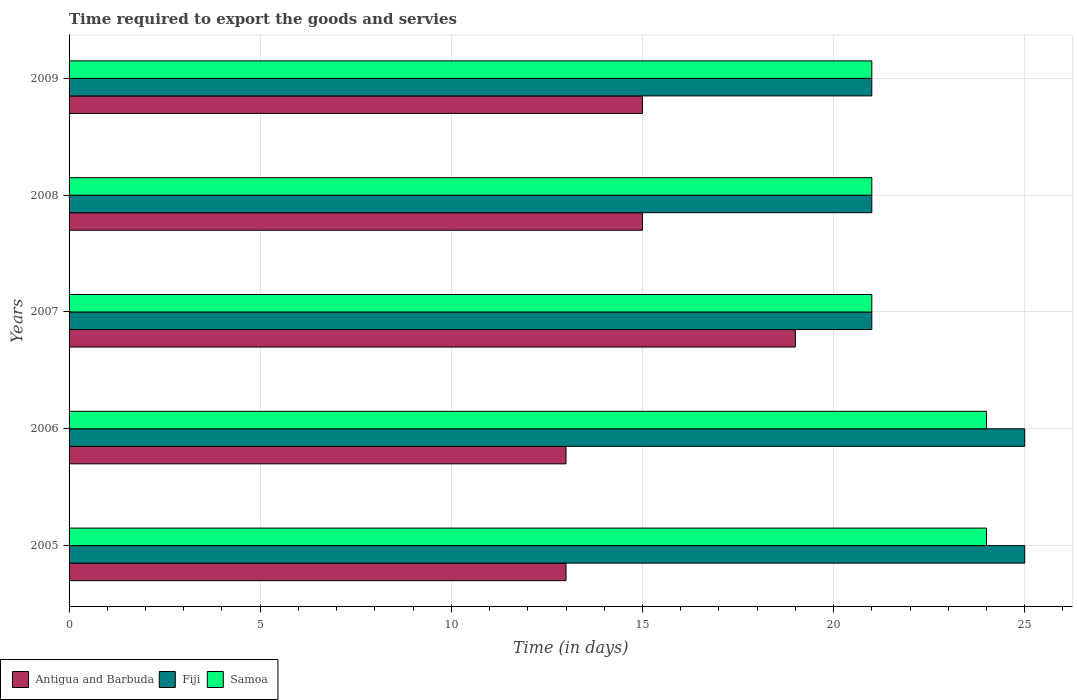Are the number of bars per tick equal to the number of legend labels?
Offer a very short reply. Yes. How many bars are there on the 3rd tick from the top?
Your answer should be compact. 3. What is the number of days required to export the goods and services in Fiji in 2007?
Offer a terse response. 21. Across all years, what is the maximum number of days required to export the goods and services in Fiji?
Make the answer very short. 25. Across all years, what is the minimum number of days required to export the goods and services in Fiji?
Give a very brief answer. 21. In which year was the number of days required to export the goods and services in Samoa maximum?
Offer a terse response. 2005. What is the total number of days required to export the goods and services in Fiji in the graph?
Your answer should be compact. 113. What is the difference between the number of days required to export the goods and services in Fiji in 2007 and that in 2008?
Your response must be concise. 0. What is the difference between the number of days required to export the goods and services in Antigua and Barbuda in 2006 and the number of days required to export the goods and services in Fiji in 2008?
Your answer should be very brief. -8. In the year 2006, what is the difference between the number of days required to export the goods and services in Samoa and number of days required to export the goods and services in Antigua and Barbuda?
Give a very brief answer. 11. Is the number of days required to export the goods and services in Fiji in 2005 less than that in 2006?
Offer a terse response. No. Is the difference between the number of days required to export the goods and services in Samoa in 2005 and 2006 greater than the difference between the number of days required to export the goods and services in Antigua and Barbuda in 2005 and 2006?
Provide a short and direct response. No. What is the difference between the highest and the lowest number of days required to export the goods and services in Samoa?
Ensure brevity in your answer.  3. In how many years, is the number of days required to export the goods and services in Samoa greater than the average number of days required to export the goods and services in Samoa taken over all years?
Give a very brief answer. 2. Is the sum of the number of days required to export the goods and services in Samoa in 2005 and 2006 greater than the maximum number of days required to export the goods and services in Fiji across all years?
Your response must be concise. Yes. What does the 2nd bar from the top in 2005 represents?
Offer a terse response. Fiji. What does the 1st bar from the bottom in 2008 represents?
Keep it short and to the point. Antigua and Barbuda. Are all the bars in the graph horizontal?
Ensure brevity in your answer.  Yes. What is the difference between two consecutive major ticks on the X-axis?
Ensure brevity in your answer.  5. Are the values on the major ticks of X-axis written in scientific E-notation?
Make the answer very short. No. Does the graph contain grids?
Your answer should be compact. Yes. Where does the legend appear in the graph?
Provide a short and direct response. Bottom left. What is the title of the graph?
Offer a terse response. Time required to export the goods and servies. What is the label or title of the X-axis?
Provide a short and direct response. Time (in days). What is the Time (in days) in Samoa in 2005?
Ensure brevity in your answer.  24. What is the Time (in days) of Antigua and Barbuda in 2007?
Ensure brevity in your answer.  19. What is the Time (in days) in Fiji in 2007?
Offer a terse response. 21. What is the Time (in days) of Samoa in 2007?
Your answer should be compact. 21. What is the Time (in days) of Antigua and Barbuda in 2009?
Give a very brief answer. 15. What is the Time (in days) of Fiji in 2009?
Provide a short and direct response. 21. What is the Time (in days) of Samoa in 2009?
Your response must be concise. 21. Across all years, what is the maximum Time (in days) in Fiji?
Make the answer very short. 25. What is the total Time (in days) in Antigua and Barbuda in the graph?
Provide a succinct answer. 75. What is the total Time (in days) in Fiji in the graph?
Offer a terse response. 113. What is the total Time (in days) in Samoa in the graph?
Make the answer very short. 111. What is the difference between the Time (in days) of Fiji in 2005 and that in 2006?
Your answer should be compact. 0. What is the difference between the Time (in days) in Fiji in 2005 and that in 2007?
Ensure brevity in your answer.  4. What is the difference between the Time (in days) in Samoa in 2005 and that in 2009?
Give a very brief answer. 3. What is the difference between the Time (in days) of Antigua and Barbuda in 2006 and that in 2007?
Make the answer very short. -6. What is the difference between the Time (in days) in Fiji in 2006 and that in 2007?
Your answer should be compact. 4. What is the difference between the Time (in days) of Antigua and Barbuda in 2006 and that in 2008?
Your response must be concise. -2. What is the difference between the Time (in days) in Fiji in 2006 and that in 2009?
Your answer should be compact. 4. What is the difference between the Time (in days) in Samoa in 2006 and that in 2009?
Your answer should be compact. 3. What is the difference between the Time (in days) in Fiji in 2007 and that in 2008?
Your answer should be compact. 0. What is the difference between the Time (in days) of Samoa in 2007 and that in 2008?
Provide a short and direct response. 0. What is the difference between the Time (in days) of Antigua and Barbuda in 2007 and that in 2009?
Offer a very short reply. 4. What is the difference between the Time (in days) in Samoa in 2008 and that in 2009?
Your answer should be very brief. 0. What is the difference between the Time (in days) of Antigua and Barbuda in 2005 and the Time (in days) of Fiji in 2006?
Offer a terse response. -12. What is the difference between the Time (in days) in Antigua and Barbuda in 2005 and the Time (in days) in Samoa in 2007?
Your answer should be compact. -8. What is the difference between the Time (in days) in Antigua and Barbuda in 2005 and the Time (in days) in Samoa in 2008?
Your response must be concise. -8. What is the difference between the Time (in days) in Fiji in 2005 and the Time (in days) in Samoa in 2008?
Offer a terse response. 4. What is the difference between the Time (in days) in Antigua and Barbuda in 2005 and the Time (in days) in Fiji in 2009?
Ensure brevity in your answer.  -8. What is the difference between the Time (in days) of Fiji in 2005 and the Time (in days) of Samoa in 2009?
Offer a very short reply. 4. What is the difference between the Time (in days) of Antigua and Barbuda in 2006 and the Time (in days) of Fiji in 2007?
Offer a very short reply. -8. What is the difference between the Time (in days) of Fiji in 2006 and the Time (in days) of Samoa in 2007?
Provide a short and direct response. 4. What is the difference between the Time (in days) in Antigua and Barbuda in 2006 and the Time (in days) in Fiji in 2008?
Ensure brevity in your answer.  -8. What is the difference between the Time (in days) of Antigua and Barbuda in 2006 and the Time (in days) of Samoa in 2008?
Give a very brief answer. -8. What is the difference between the Time (in days) of Antigua and Barbuda in 2006 and the Time (in days) of Samoa in 2009?
Provide a succinct answer. -8. What is the difference between the Time (in days) of Fiji in 2006 and the Time (in days) of Samoa in 2009?
Ensure brevity in your answer.  4. What is the difference between the Time (in days) of Antigua and Barbuda in 2007 and the Time (in days) of Samoa in 2009?
Your answer should be compact. -2. What is the difference between the Time (in days) of Fiji in 2007 and the Time (in days) of Samoa in 2009?
Your answer should be very brief. 0. What is the difference between the Time (in days) in Fiji in 2008 and the Time (in days) in Samoa in 2009?
Your answer should be compact. 0. What is the average Time (in days) of Fiji per year?
Provide a succinct answer. 22.6. What is the average Time (in days) in Samoa per year?
Keep it short and to the point. 22.2. In the year 2006, what is the difference between the Time (in days) of Antigua and Barbuda and Time (in days) of Fiji?
Keep it short and to the point. -12. In the year 2006, what is the difference between the Time (in days) of Fiji and Time (in days) of Samoa?
Give a very brief answer. 1. In the year 2008, what is the difference between the Time (in days) in Antigua and Barbuda and Time (in days) in Fiji?
Give a very brief answer. -6. In the year 2008, what is the difference between the Time (in days) of Antigua and Barbuda and Time (in days) of Samoa?
Make the answer very short. -6. In the year 2009, what is the difference between the Time (in days) in Antigua and Barbuda and Time (in days) in Fiji?
Your answer should be compact. -6. In the year 2009, what is the difference between the Time (in days) in Fiji and Time (in days) in Samoa?
Your answer should be compact. 0. What is the ratio of the Time (in days) in Antigua and Barbuda in 2005 to that in 2007?
Offer a very short reply. 0.68. What is the ratio of the Time (in days) in Fiji in 2005 to that in 2007?
Ensure brevity in your answer.  1.19. What is the ratio of the Time (in days) of Antigua and Barbuda in 2005 to that in 2008?
Provide a succinct answer. 0.87. What is the ratio of the Time (in days) in Fiji in 2005 to that in 2008?
Provide a short and direct response. 1.19. What is the ratio of the Time (in days) in Antigua and Barbuda in 2005 to that in 2009?
Give a very brief answer. 0.87. What is the ratio of the Time (in days) in Fiji in 2005 to that in 2009?
Provide a short and direct response. 1.19. What is the ratio of the Time (in days) in Antigua and Barbuda in 2006 to that in 2007?
Provide a succinct answer. 0.68. What is the ratio of the Time (in days) of Fiji in 2006 to that in 2007?
Your response must be concise. 1.19. What is the ratio of the Time (in days) of Antigua and Barbuda in 2006 to that in 2008?
Give a very brief answer. 0.87. What is the ratio of the Time (in days) of Fiji in 2006 to that in 2008?
Your answer should be compact. 1.19. What is the ratio of the Time (in days) in Samoa in 2006 to that in 2008?
Make the answer very short. 1.14. What is the ratio of the Time (in days) of Antigua and Barbuda in 2006 to that in 2009?
Keep it short and to the point. 0.87. What is the ratio of the Time (in days) of Fiji in 2006 to that in 2009?
Your answer should be very brief. 1.19. What is the ratio of the Time (in days) of Samoa in 2006 to that in 2009?
Make the answer very short. 1.14. What is the ratio of the Time (in days) of Antigua and Barbuda in 2007 to that in 2008?
Ensure brevity in your answer.  1.27. What is the ratio of the Time (in days) of Antigua and Barbuda in 2007 to that in 2009?
Offer a very short reply. 1.27. What is the ratio of the Time (in days) of Fiji in 2007 to that in 2009?
Offer a very short reply. 1. What is the difference between the highest and the second highest Time (in days) of Antigua and Barbuda?
Keep it short and to the point. 4. What is the difference between the highest and the second highest Time (in days) in Fiji?
Your response must be concise. 0. What is the difference between the highest and the second highest Time (in days) of Samoa?
Provide a short and direct response. 0. What is the difference between the highest and the lowest Time (in days) in Antigua and Barbuda?
Your response must be concise. 6. What is the difference between the highest and the lowest Time (in days) of Fiji?
Your answer should be compact. 4. 